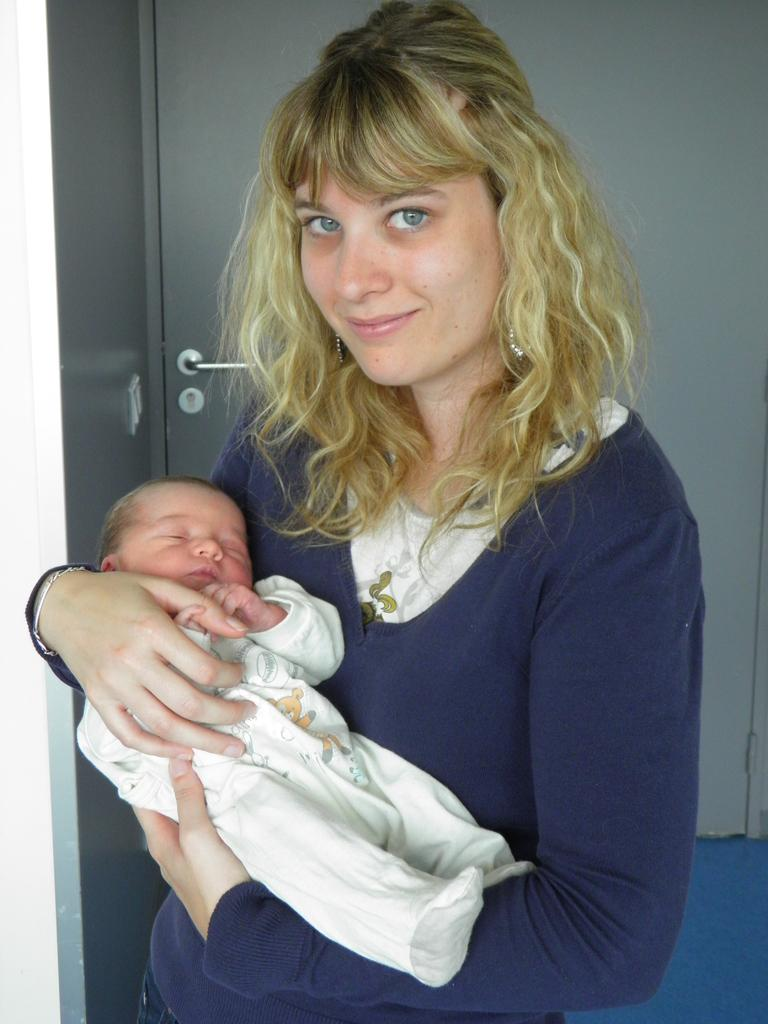Who is the main subject in the image? There is a woman in the image. What is the woman doing in the image? The woman is holding a baby in her arms. Who is the woman looking at in the image? The woman is looking at someone, but their identity is not specified in the image. What type of cheese is the woman holding in the image? There is no cheese present in the image; the woman is holding a baby in her arms. How many hands does the woman have in the image? The number of hands the woman has is not specified in the image, but it is typical for a person to have two hands. 